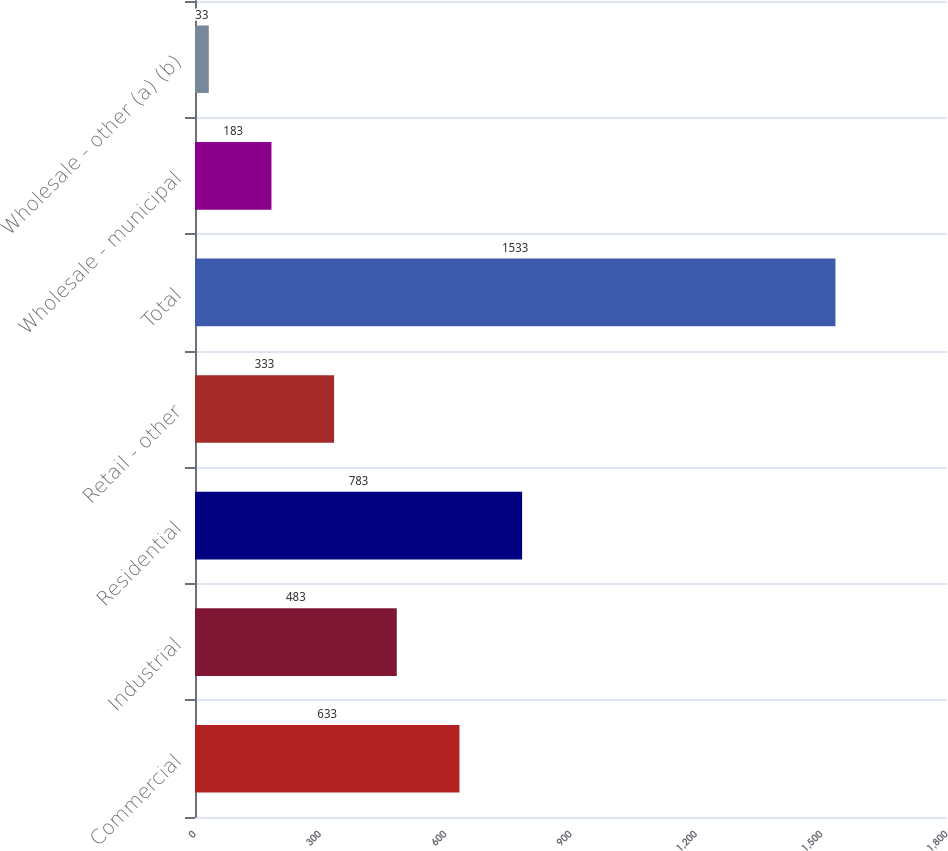Convert chart to OTSL. <chart><loc_0><loc_0><loc_500><loc_500><bar_chart><fcel>Commercial<fcel>Industrial<fcel>Residential<fcel>Retail - other<fcel>Total<fcel>Wholesale - municipal<fcel>Wholesale - other (a) (b)<nl><fcel>633<fcel>483<fcel>783<fcel>333<fcel>1533<fcel>183<fcel>33<nl></chart> 